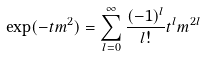Convert formula to latex. <formula><loc_0><loc_0><loc_500><loc_500>\exp ( - t m ^ { 2 } ) = \sum _ { l = 0 } ^ { \infty } \frac { ( - 1 ) ^ { l } } { l ! } t ^ { l } m ^ { 2 l }</formula> 